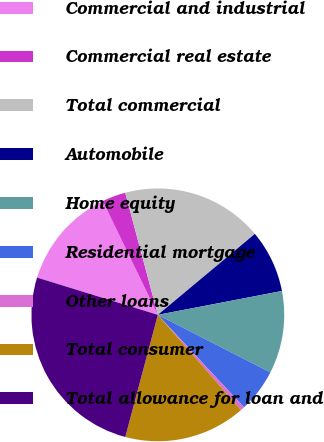<chart> <loc_0><loc_0><loc_500><loc_500><pie_chart><fcel>Commercial and industrial<fcel>Commercial real estate<fcel>Total commercial<fcel>Automobile<fcel>Home equity<fcel>Residential mortgage<fcel>Other loans<fcel>Total consumer<fcel>Total allowance for loan and<nl><fcel>13.06%<fcel>3.02%<fcel>18.08%<fcel>8.04%<fcel>10.55%<fcel>5.53%<fcel>0.51%<fcel>15.57%<fcel>25.61%<nl></chart> 